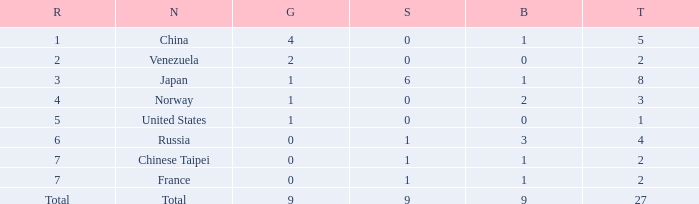What is the sum of Bronze when the total is more than 27? None. Would you be able to parse every entry in this table? {'header': ['R', 'N', 'G', 'S', 'B', 'T'], 'rows': [['1', 'China', '4', '0', '1', '5'], ['2', 'Venezuela', '2', '0', '0', '2'], ['3', 'Japan', '1', '6', '1', '8'], ['4', 'Norway', '1', '0', '2', '3'], ['5', 'United States', '1', '0', '0', '1'], ['6', 'Russia', '0', '1', '3', '4'], ['7', 'Chinese Taipei', '0', '1', '1', '2'], ['7', 'France', '0', '1', '1', '2'], ['Total', 'Total', '9', '9', '9', '27']]} 